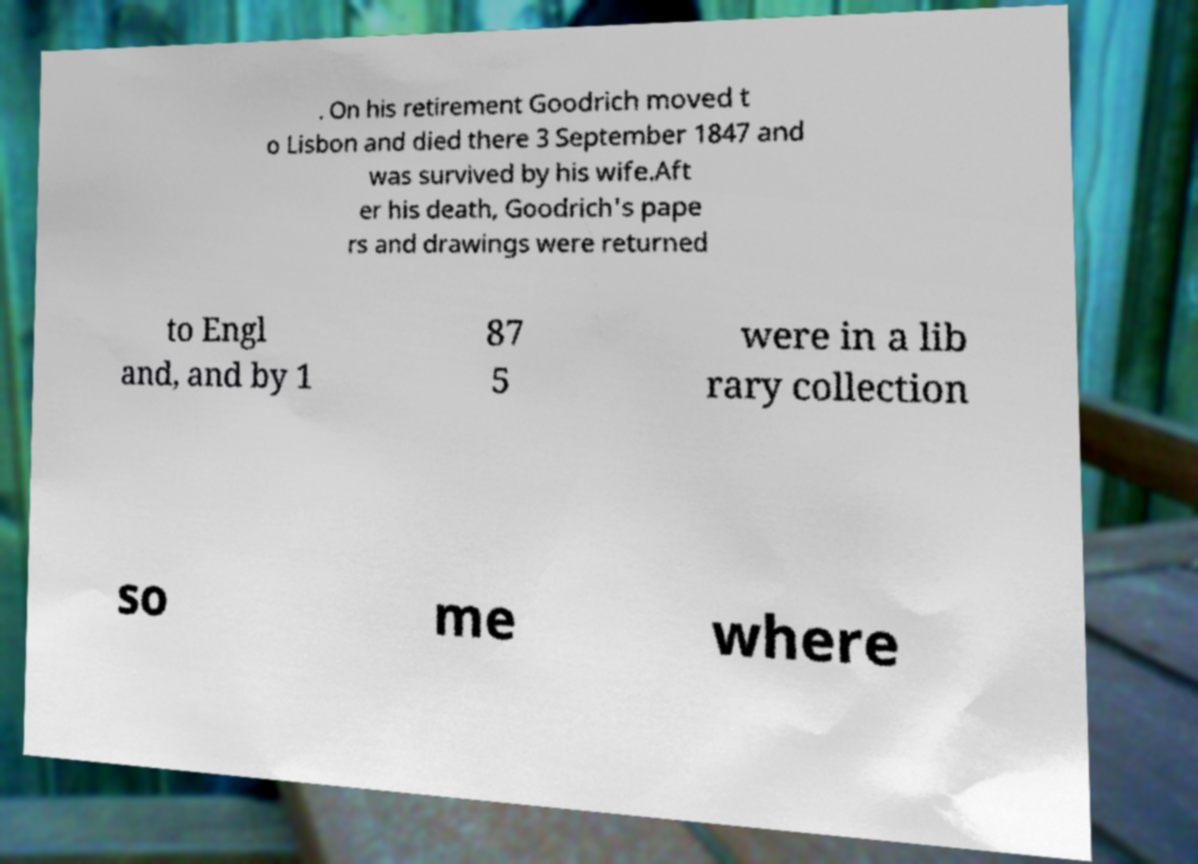Could you extract and type out the text from this image? . On his retirement Goodrich moved t o Lisbon and died there 3 September 1847 and was survived by his wife.Aft er his death, Goodrich's pape rs and drawings were returned to Engl and, and by 1 87 5 were in a lib rary collection so me where 